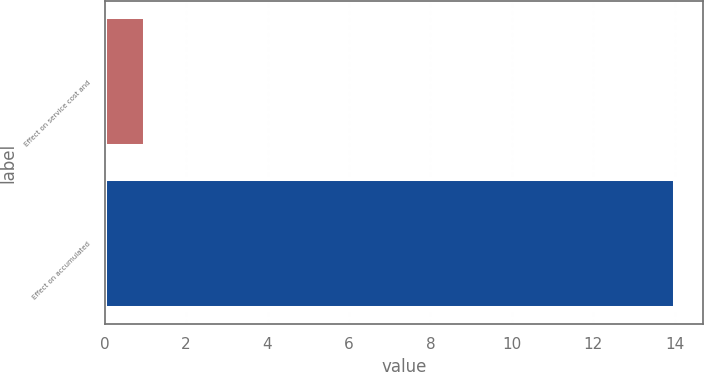<chart> <loc_0><loc_0><loc_500><loc_500><bar_chart><fcel>Effect on service cost and<fcel>Effect on accumulated<nl><fcel>1<fcel>14<nl></chart> 